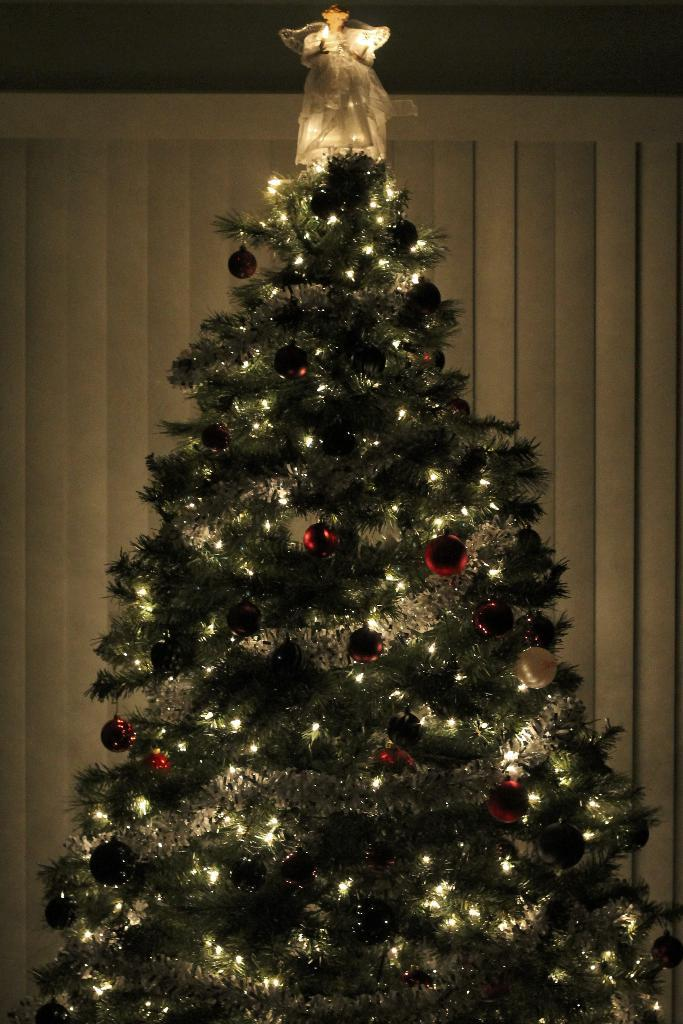What type of tree is in the image? There is an xmas tree in the image. How is the xmas tree decorated? The xmas tree is decorated with lights and balls. What can be seen in the background of the image? There is a wall in the background of the image. How many cans of paint are needed to balance the xmas tree in the image? There are no cans of paint present in the image, and the xmas tree is not in need of balancing. 